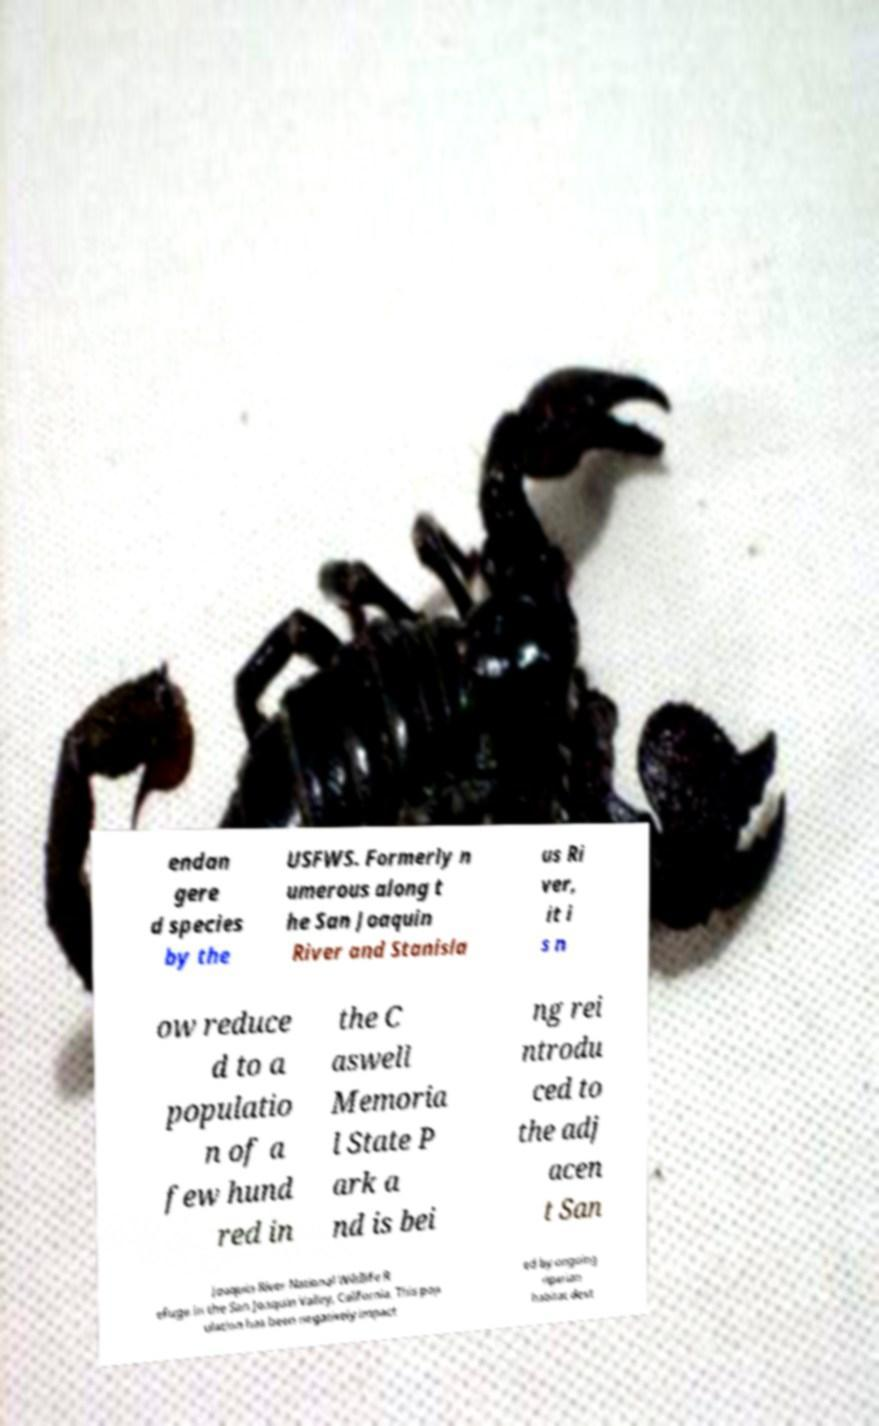Please read and relay the text visible in this image. What does it say? endan gere d species by the USFWS. Formerly n umerous along t he San Joaquin River and Stanisla us Ri ver, it i s n ow reduce d to a populatio n of a few hund red in the C aswell Memoria l State P ark a nd is bei ng rei ntrodu ced to the adj acen t San Joaquin River National Wildlife R efuge in the San Joaquin Valley, California. This pop ulation has been negatively impact ed by ongoing riparian habitat dest 